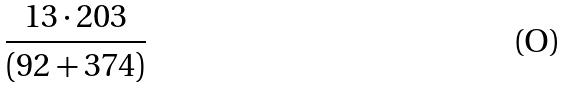Convert formula to latex. <formula><loc_0><loc_0><loc_500><loc_500>\frac { 1 3 \cdot 2 0 3 } { ( 9 2 + 3 7 4 ) }</formula> 